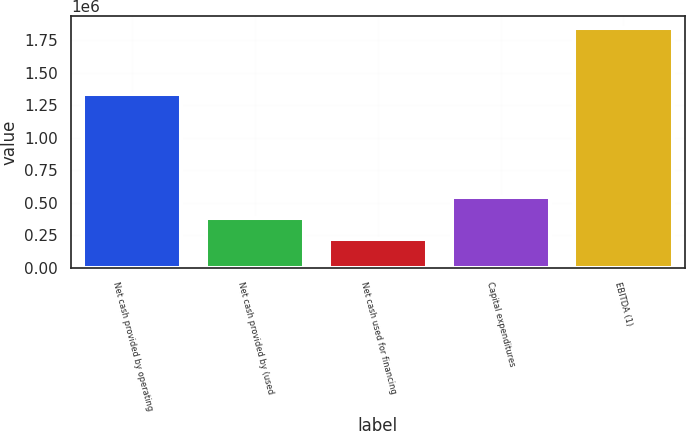Convert chart. <chart><loc_0><loc_0><loc_500><loc_500><bar_chart><fcel>Net cash provided by operating<fcel>Net cash provided by (used<fcel>Net cash used for financing<fcel>Capital expenditures<fcel>EBITDA (1)<nl><fcel>1.33839e+06<fcel>379587<fcel>217082<fcel>542092<fcel>1.84213e+06<nl></chart> 